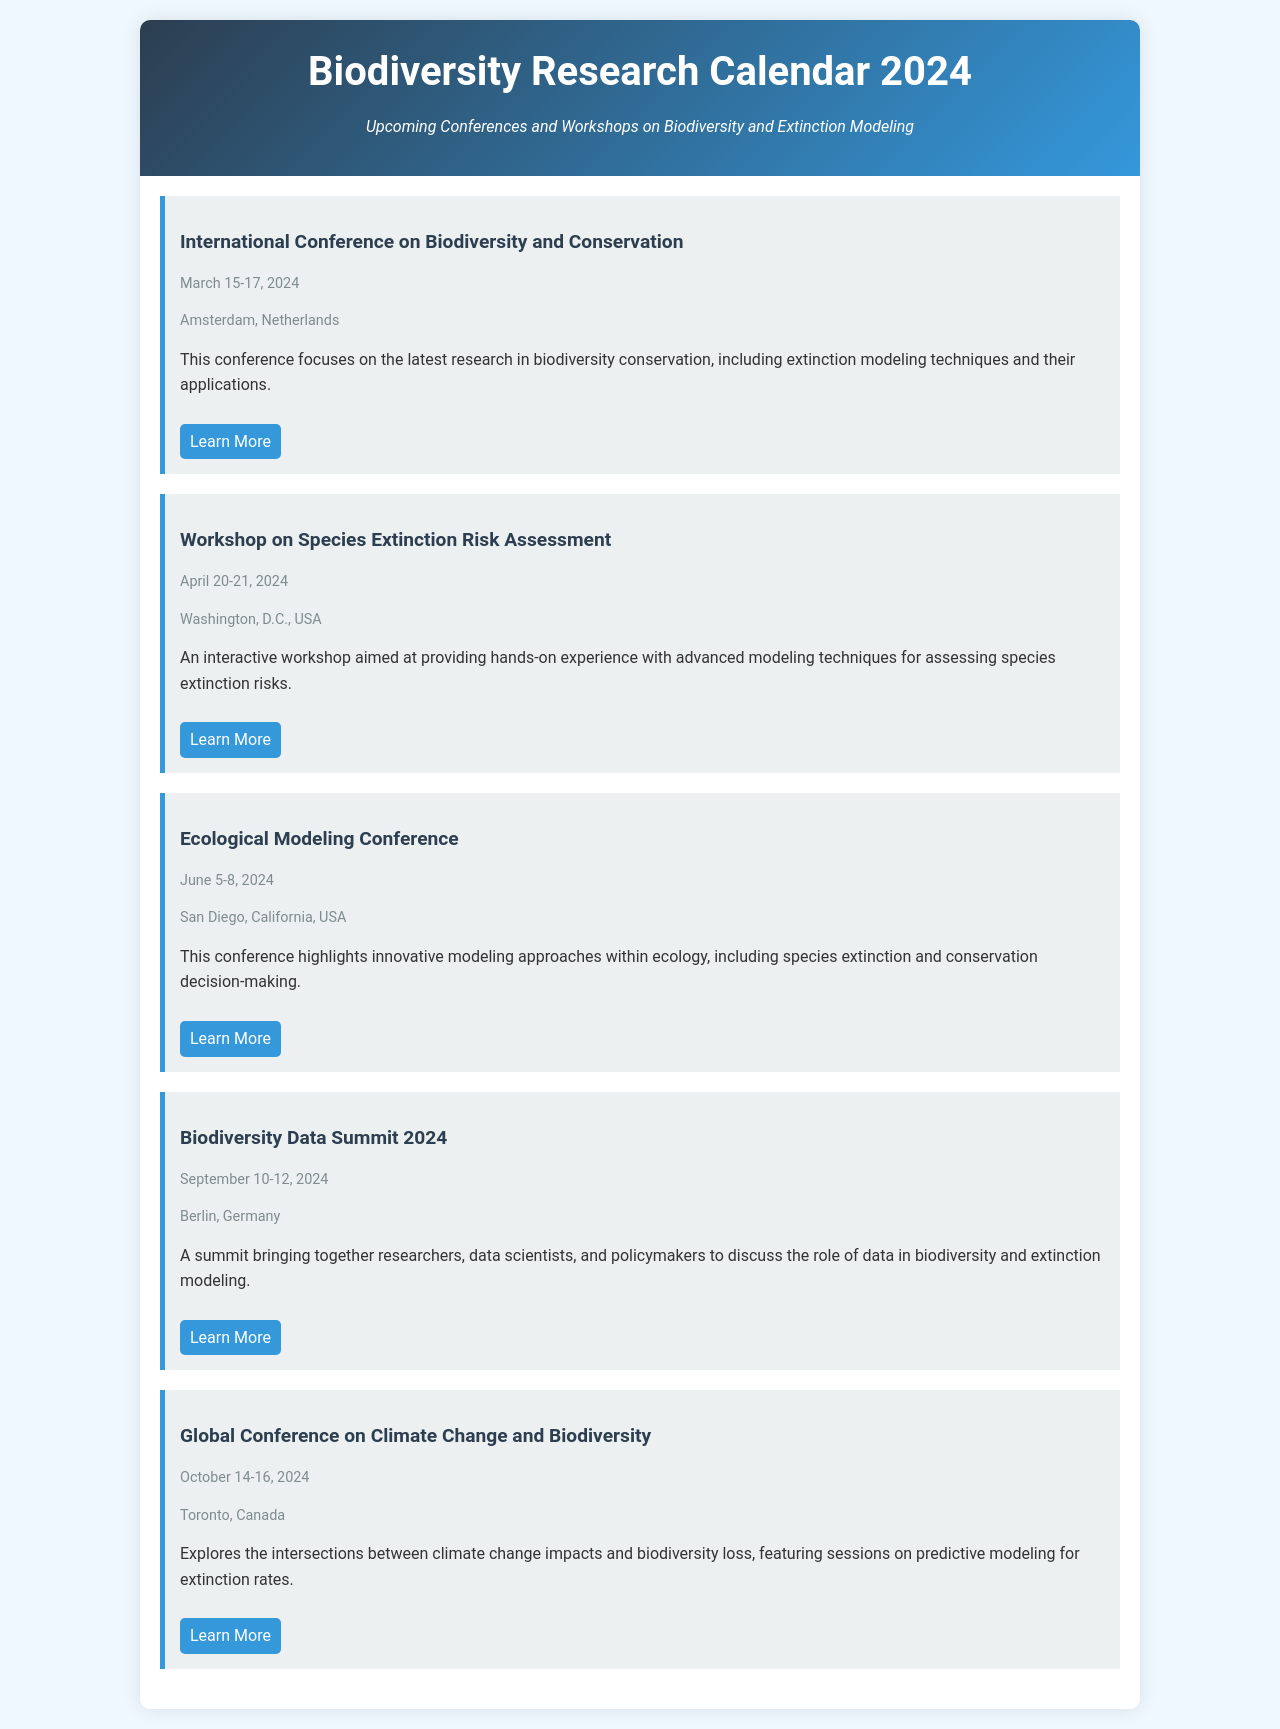what is the date of the International Conference on Biodiversity and Conservation? The date listed for the conference is March 15-17, 2024.
Answer: March 15-17, 2024 where will the Workshop on Species Extinction Risk Assessment be held? The location of the workshop is Washington, D.C., USA.
Answer: Washington, D.C., USA what is the focus of the Ecological Modeling Conference? The conference focuses on innovative modeling approaches within ecology, including species extinction and conservation decision-making.
Answer: Innovative modeling approaches which event will discuss data in biodiversity and extinction modeling? The event focused on data in biodiversity and extinction modeling is the Biodiversity Data Summit 2024.
Answer: Biodiversity Data Summit 2024 how many days will the Global Conference on Climate Change and Biodiversity last? The duration of the conference is three days, from October 14 to October 16, 2024.
Answer: Three days which conference is the first on the schedule? The first conference on the schedule is the International Conference on Biodiversity and Conservation.
Answer: International Conference on Biodiversity and Conservation what is the main theme of the Global Conference on Climate Change and Biodiversity? The main theme of the conference is the intersections between climate change impacts and biodiversity loss.
Answer: Climate change impacts and biodiversity loss who is the target audience for the Biodiversity Data Summit 2024? The summit targets researchers, data scientists, and policymakers.
Answer: Researchers, data scientists, and policymakers 